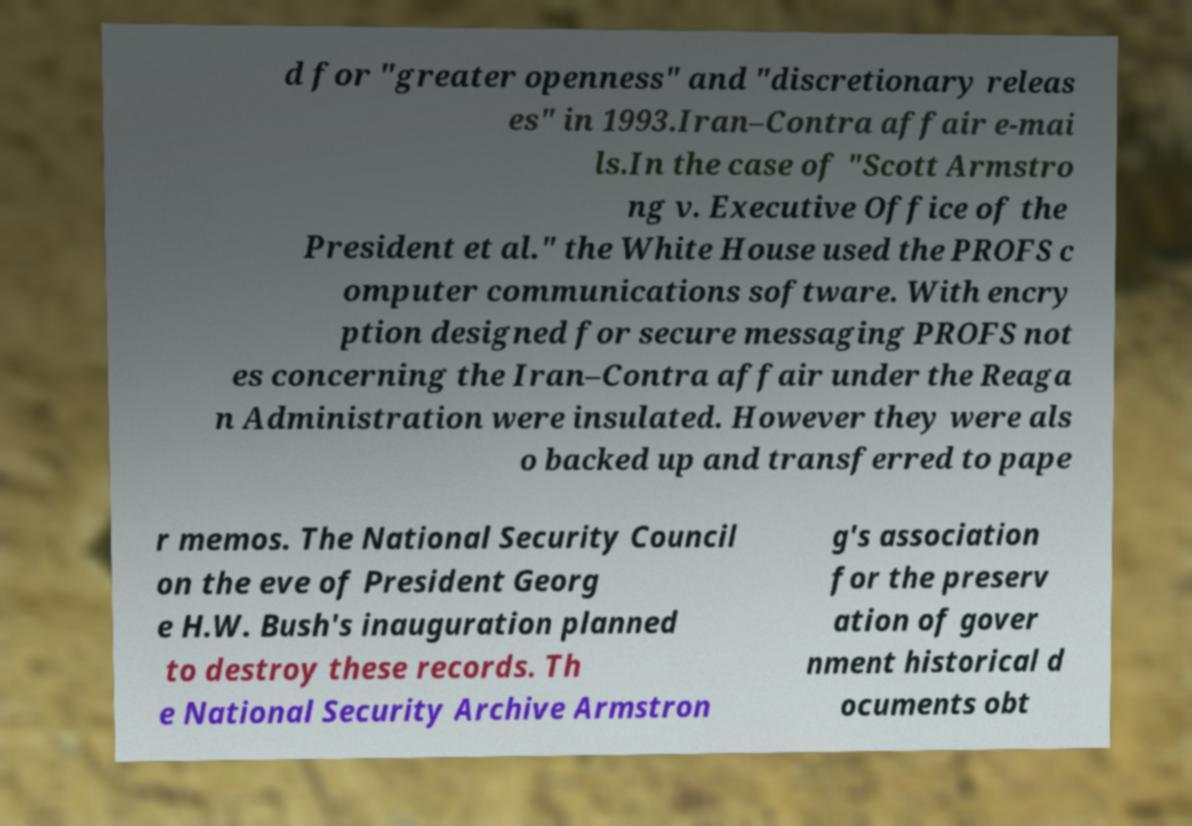Could you assist in decoding the text presented in this image and type it out clearly? d for "greater openness" and "discretionary releas es" in 1993.Iran–Contra affair e-mai ls.In the case of "Scott Armstro ng v. Executive Office of the President et al." the White House used the PROFS c omputer communications software. With encry ption designed for secure messaging PROFS not es concerning the Iran–Contra affair under the Reaga n Administration were insulated. However they were als o backed up and transferred to pape r memos. The National Security Council on the eve of President Georg e H.W. Bush's inauguration planned to destroy these records. Th e National Security Archive Armstron g's association for the preserv ation of gover nment historical d ocuments obt 